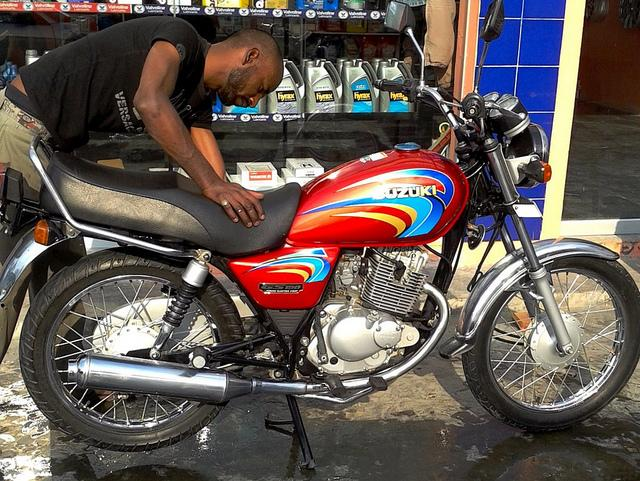What company makes the vehicle? suzuki 